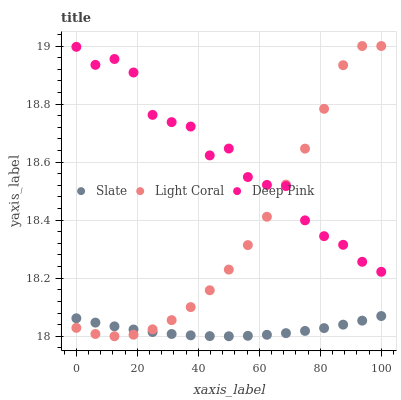Does Slate have the minimum area under the curve?
Answer yes or no. Yes. Does Deep Pink have the maximum area under the curve?
Answer yes or no. Yes. Does Deep Pink have the minimum area under the curve?
Answer yes or no. No. Does Slate have the maximum area under the curve?
Answer yes or no. No. Is Slate the smoothest?
Answer yes or no. Yes. Is Deep Pink the roughest?
Answer yes or no. Yes. Is Deep Pink the smoothest?
Answer yes or no. No. Is Slate the roughest?
Answer yes or no. No. Does Slate have the lowest value?
Answer yes or no. Yes. Does Deep Pink have the lowest value?
Answer yes or no. No. Does Light Coral have the highest value?
Answer yes or no. Yes. Does Deep Pink have the highest value?
Answer yes or no. No. Is Slate less than Deep Pink?
Answer yes or no. Yes. Is Deep Pink greater than Slate?
Answer yes or no. Yes. Does Light Coral intersect Slate?
Answer yes or no. Yes. Is Light Coral less than Slate?
Answer yes or no. No. Is Light Coral greater than Slate?
Answer yes or no. No. Does Slate intersect Deep Pink?
Answer yes or no. No. 